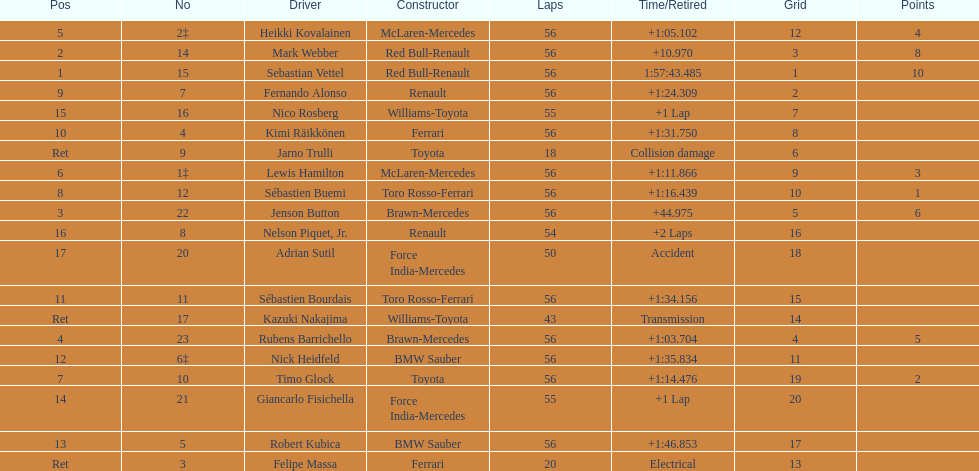Which driver is the only driver who retired because of collision damage? Jarno Trulli. 